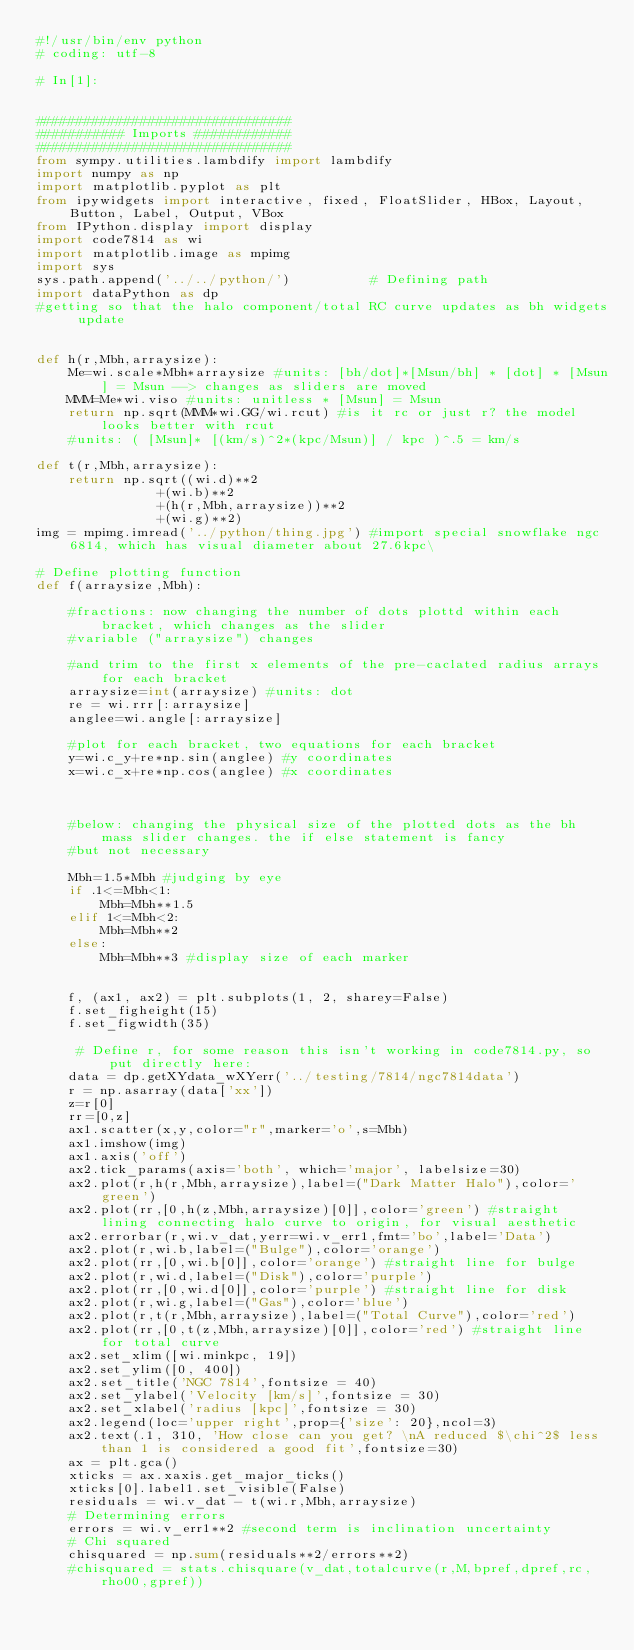Convert code to text. <code><loc_0><loc_0><loc_500><loc_500><_Python_>#!/usr/bin/env python
# coding: utf-8

# In[1]:


################################
########### Imports ############
################################
from sympy.utilities.lambdify import lambdify
import numpy as np
import matplotlib.pyplot as plt
from ipywidgets import interactive, fixed, FloatSlider, HBox, Layout, Button, Label, Output, VBox
from IPython.display import display
import code7814 as wi
import matplotlib.image as mpimg
import sys
sys.path.append('../../python/')          # Defining path
import dataPython as dp
#getting so that the halo component/total RC curve updates as bh widgets update


def h(r,Mbh,arraysize):
    Me=wi.scale*Mbh*arraysize #units: [bh/dot]*[Msun/bh] * [dot] * [Msun] = Msun --> changes as sliders are moved
    MMM=Me*wi.viso #units: unitless * [Msun] = Msun
    return np.sqrt(MMM*wi.GG/wi.rcut) #is it rc or just r? the model looks better with rcut 
    #units: ( [Msun]* [(km/s)^2*(kpc/Msun)] / kpc )^.5 = km/s                                                                

def t(r,Mbh,arraysize):
    return np.sqrt((wi.d)**2
               +(wi.b)**2
               +(h(r,Mbh,arraysize))**2
               +(wi.g)**2)
img = mpimg.imread('../python/thing.jpg') #import special snowflake ngc 6814, which has visual diameter about 27.6kpc\ 

# Define plotting function
def f(arraysize,Mbh):
    
    #fractions: now changing the number of dots plottd within each bracket, which changes as the slider 
    #variable ("arraysize") changes
    
    #and trim to the first x elements of the pre-caclated radius arrays for each bracket
    arraysize=int(arraysize) #units: dot
    re = wi.rrr[:arraysize]
    anglee=wi.angle[:arraysize]
    
    #plot for each bracket, two equations for each bracket
    y=wi.c_y+re*np.sin(anglee) #y coordinates
    x=wi.c_x+re*np.cos(anglee) #x coordinates
    
    
    
    #below: changing the physical size of the plotted dots as the bh mass slider changes. the if else statement is fancy
    #but not necessary
    
    Mbh=1.5*Mbh #judging by eye
    if .1<=Mbh<1:
        Mbh=Mbh**1.5
    elif 1<=Mbh<2:
        Mbh=Mbh**2
    else:
        Mbh=Mbh**3 #display size of each marker
        
    
    f, (ax1, ax2) = plt.subplots(1, 2, sharey=False)
    f.set_figheight(15)
    f.set_figwidth(35)
    
     # Define r, for some reason this isn't working in code7814.py, so put directly here:
    data = dp.getXYdata_wXYerr('../testing/7814/ngc7814data')
    r = np.asarray(data['xx'])
    z=r[0]
    rr=[0,z]
    ax1.scatter(x,y,color="r",marker='o',s=Mbh)
    ax1.imshow(img)
    ax1.axis('off')
    ax2.tick_params(axis='both', which='major', labelsize=30)
    ax2.plot(r,h(r,Mbh,arraysize),label=("Dark Matter Halo"),color='green')
    ax2.plot(rr,[0,h(z,Mbh,arraysize)[0]],color='green') #straight lining connecting halo curve to origin, for visual aesthetic
    ax2.errorbar(r,wi.v_dat,yerr=wi.v_err1,fmt='bo',label='Data')
    ax2.plot(r,wi.b,label=("Bulge"),color='orange')
    ax2.plot(rr,[0,wi.b[0]],color='orange') #straight line for bulge
    ax2.plot(r,wi.d,label=("Disk"),color='purple')
    ax2.plot(rr,[0,wi.d[0]],color='purple') #straight line for disk
    ax2.plot(r,wi.g,label=("Gas"),color='blue')
    ax2.plot(r,t(r,Mbh,arraysize),label=("Total Curve"),color='red')
    ax2.plot(rr,[0,t(z,Mbh,arraysize)[0]],color='red') #straight line for total curve
    ax2.set_xlim([wi.minkpc, 19])
    ax2.set_ylim([0, 400])
    ax2.set_title('NGC 7814',fontsize = 40)
    ax2.set_ylabel('Velocity [km/s]',fontsize = 30)
    ax2.set_xlabel('radius [kpc]',fontsize = 30)
    ax2.legend(loc='upper right',prop={'size': 20},ncol=3)
    ax2.text(.1, 310, 'How close can you get? \nA reduced $\chi^2$ less than 1 is considered a good fit',fontsize=30)
    ax = plt.gca()
    xticks = ax.xaxis.get_major_ticks() 
    xticks[0].label1.set_visible(False)
    residuals = wi.v_dat - t(wi.r,Mbh,arraysize)
    # Determining errors
    errors = wi.v_err1**2 #second term is inclination uncertainty
    # Chi squared
    chisquared = np.sum(residuals**2/errors**2)
    #chisquared = stats.chisquare(v_dat,totalcurve(r,M,bpref,dpref,rc,rho00,gpref))</code> 